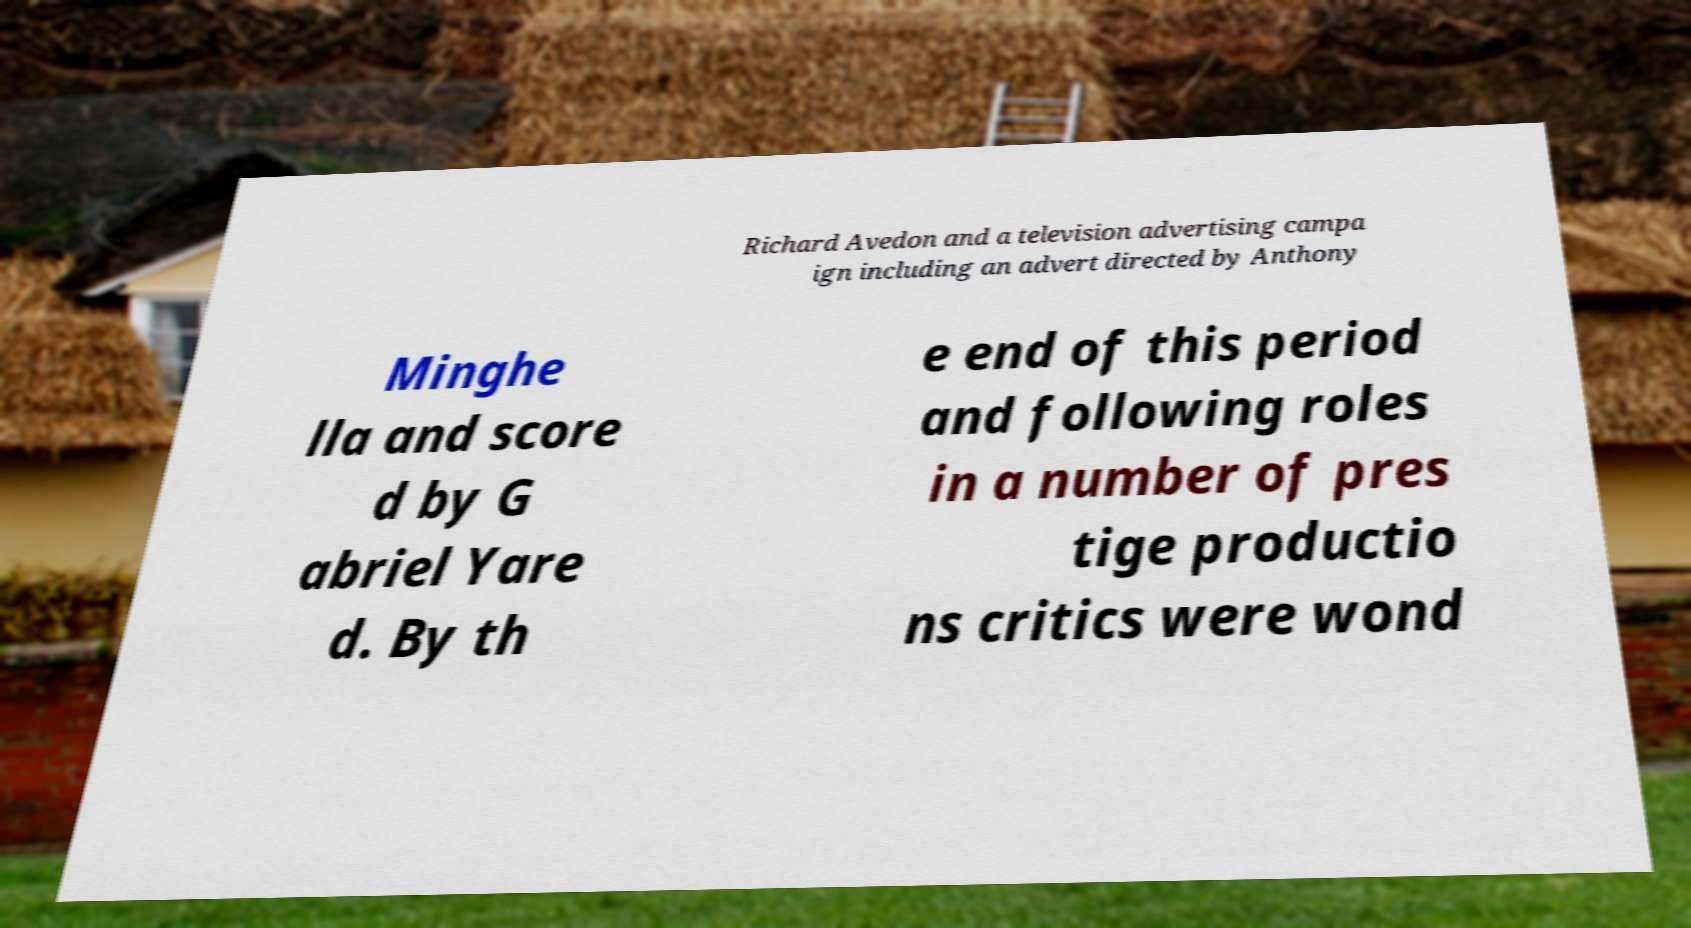Could you assist in decoding the text presented in this image and type it out clearly? Richard Avedon and a television advertising campa ign including an advert directed by Anthony Minghe lla and score d by G abriel Yare d. By th e end of this period and following roles in a number of pres tige productio ns critics were wond 